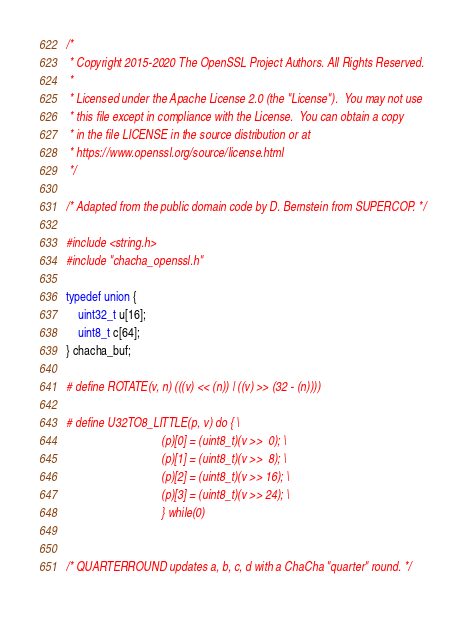Convert code to text. <code><loc_0><loc_0><loc_500><loc_500><_C_>/*
 * Copyright 2015-2020 The OpenSSL Project Authors. All Rights Reserved.
 *
 * Licensed under the Apache License 2.0 (the "License").  You may not use
 * this file except in compliance with the License.  You can obtain a copy
 * in the file LICENSE in the source distribution or at
 * https://www.openssl.org/source/license.html
 */

/* Adapted from the public domain code by D. Bernstein from SUPERCOP. */

#include <string.h>
#include "chacha_openssl.h"

typedef union {
    uint32_t u[16];
    uint8_t c[64];
} chacha_buf;

# define ROTATE(v, n) (((v) << (n)) | ((v) >> (32 - (n))))

# define U32TO8_LITTLE(p, v) do { \
                                (p)[0] = (uint8_t)(v >>  0); \
                                (p)[1] = (uint8_t)(v >>  8); \
                                (p)[2] = (uint8_t)(v >> 16); \
                                (p)[3] = (uint8_t)(v >> 24); \
                                } while(0)


/* QUARTERROUND updates a, b, c, d with a ChaCha "quarter" round. */</code> 